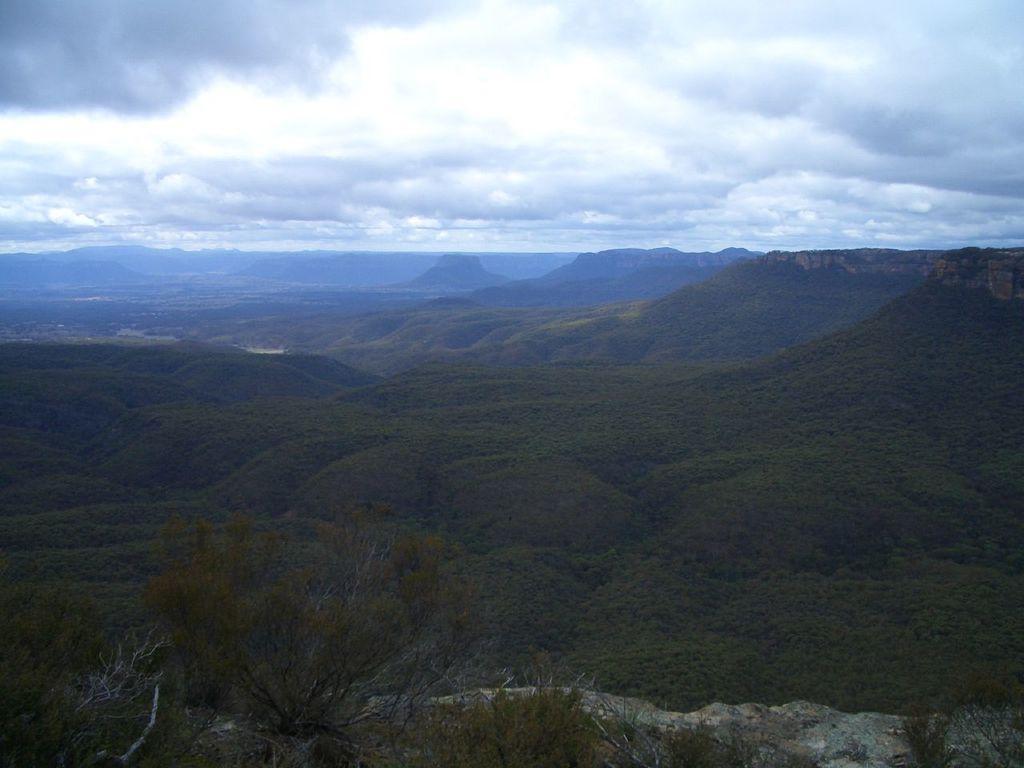Can you describe this image briefly? In this picture I can observe some trees. There are some hills. In the background there is a sky with some clouds. 